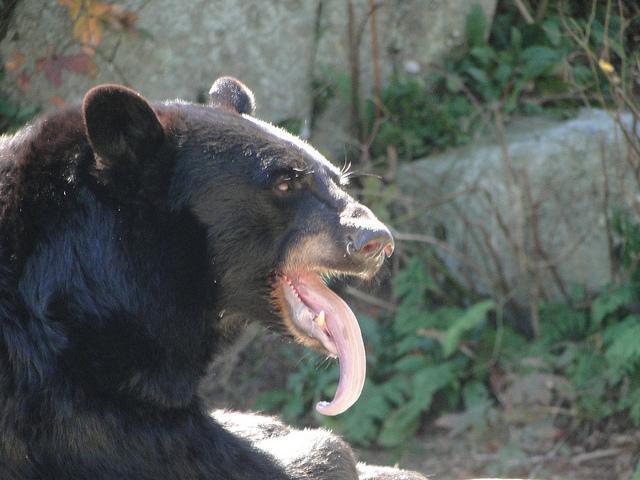How many claws are seen?
Give a very brief answer. 0. 